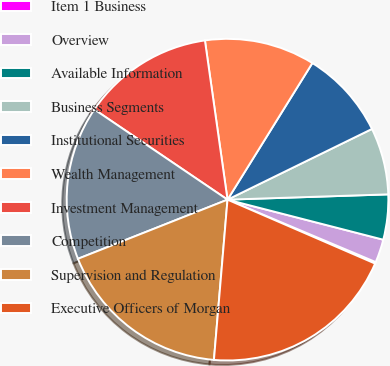<chart> <loc_0><loc_0><loc_500><loc_500><pie_chart><fcel>Item 1 Business<fcel>Overview<fcel>Available Information<fcel>Business Segments<fcel>Institutional Securities<fcel>Wealth Management<fcel>Investment Management<fcel>Competition<fcel>Supervision and Regulation<fcel>Executive Officers of Morgan<nl><fcel>0.16%<fcel>2.34%<fcel>4.53%<fcel>6.72%<fcel>8.91%<fcel>11.09%<fcel>13.28%<fcel>15.47%<fcel>17.66%<fcel>19.84%<nl></chart> 